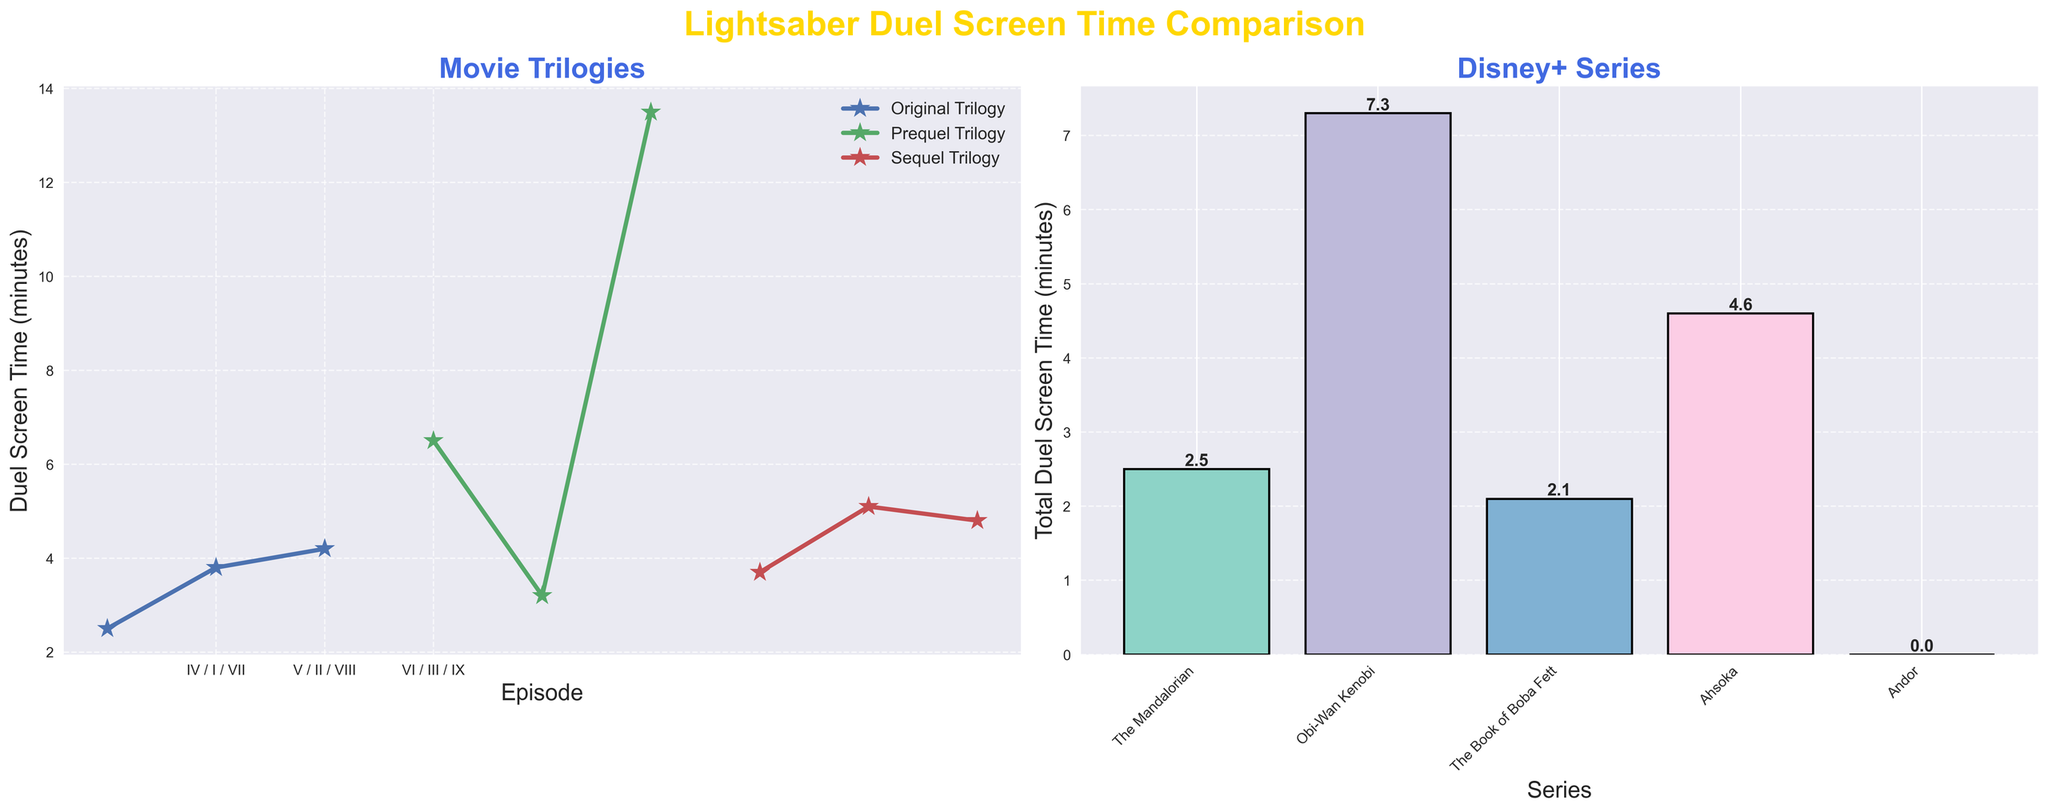Which Star Wars trilogy has the highest average lightsaber duel screen time per episode? To find the average for each trilogy, sum the duel times and divide by the number of episodes in that trilogy. For the Original Trilogy (2.5 + 3.8 + 4.2) / 3 = 3.5 minutes. For the Prequel Trilogy (6.5 + 3.2 + 13.5) / 3 = 7.7 minutes. For the Sequel Trilogy (3.7 + 5.1 + 4.8) / 3 = 4.53 minutes. The Prequel Trilogy has the highest average.
Answer: Prequel Trilogy Which Disney+ series has the longest total lightsaber duel screen time? Summing the duel times for each series: "The Mandalorian" (0.5 + 1.2 + 0.8) = 2.5 minutes, "Obi-Wan Kenobi" = 7.3 minutes, "The Book of Boba Fett" = 2.1 minutes, "Ahsoka" = 4.6 minutes, and "Andor" = 0.0 minutes. "Obi-Wan Kenobi" has the longest total screen time at 7.3 minutes.
Answer: Obi-Wan Kenobi What is the total lightsaber duel screen time for all movies in comparison to all series? Sum the duel times for all trilogies: (2.5 + 3.8 + 4.2 + 6.5 + 3.2 + 13.5 + 3.7 + 5.1 + 4.8) = 47.3 minutes. Sum for all Disney+ series: (0.5 + 1.2 + 0.8 + 7.3 + 2.1 + 4.6 + 0.0) = 16.5 minutes. Comparing both, movies have a total of 47.3 minutes and series have 16.5 minutes.
Answer: Movies: 47.3 minutes, Series: 16.5 minutes Which episode of the Original Trilogy has the shortest lightsaber duel screen time? Comparing the duel times for each episode in the Original Trilogy: Episode IV = 2.5 minutes, Episode V = 3.8 minutes, Episode VI = 4.2 minutes. Episode IV has the shortest screen time at 2.5 minutes.
Answer: Episode IV How does "The Mandalorian" compare visually in lightsaber duel screen time against "Obi-Wan Kenobi" in the bar chart? Visually check the heights of the bars for "The Mandalorian" and "Obi-Wan Kenobi" in the bar chart. "The Mandalorian" is much shorter compared to "Obi-Wan Kenobi", indicating significantly less total screen time for duels.
Answer: "The Mandalorian" has less screen time than "Obi-Wan Kenobi" Which episode from the Sequel Trilogy features the longest lightsaber duel? Comparing the duel times for the Sequel Trilogy: Episode VII = 3.7 minutes, Episode VIII = 5.1 minutes, and Episode IX = 4.8 minutes. Episode VIII has the longest duel at 5.1 minutes.
Answer: Episode VIII Is there any Disney+ series that has no lightsaber duel screen time? Based on the bar chart, "Andor" has a total duel screen time of 0.0 minutes.
Answer: Andor 